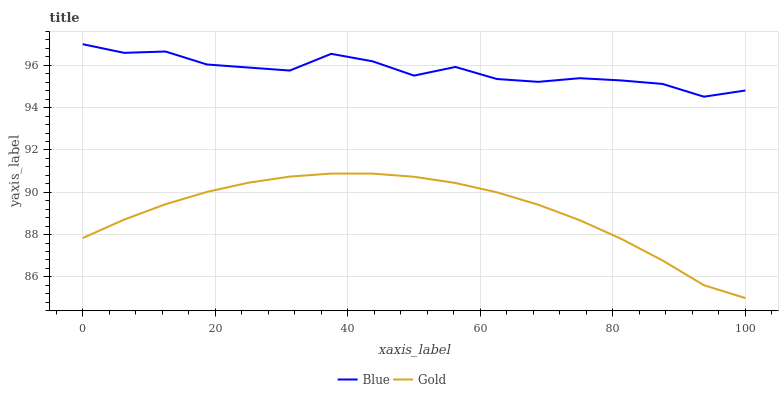Does Gold have the maximum area under the curve?
Answer yes or no. No. Is Gold the roughest?
Answer yes or no. No. Does Gold have the highest value?
Answer yes or no. No. Is Gold less than Blue?
Answer yes or no. Yes. Is Blue greater than Gold?
Answer yes or no. Yes. Does Gold intersect Blue?
Answer yes or no. No. 